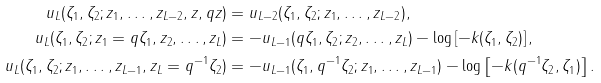Convert formula to latex. <formula><loc_0><loc_0><loc_500><loc_500>u _ { L } ( \zeta _ { 1 } , \zeta _ { 2 } ; z _ { 1 } , \dots , z _ { L - 2 } , z , q z ) & = u _ { L - 2 } ( \zeta _ { 1 } , \zeta _ { 2 } ; z _ { 1 } , \dots , z _ { L - 2 } ) , \\ u _ { L } ( \zeta _ { 1 } , \zeta _ { 2 } ; z _ { 1 } = q \zeta _ { 1 } , z _ { 2 } , \dots , z _ { L } ) & = - u _ { L - 1 } ( q \zeta _ { 1 } , \zeta _ { 2 } ; z _ { 2 } , \dots , z _ { L } ) - \log \left [ - k ( \zeta _ { 1 } , \zeta _ { 2 } ) \right ] , \\ u _ { L } ( \zeta _ { 1 } , \zeta _ { 2 } ; z _ { 1 } , \dots , z _ { L - 1 } , z _ { L } = q ^ { - 1 } \zeta _ { 2 } ) & = - u _ { L - 1 } ( \zeta _ { 1 } , q ^ { - 1 } \zeta _ { 2 } ; z _ { 1 } , \dots , z _ { L - 1 } ) - \log \left [ - k ( q ^ { - 1 } \zeta _ { 2 } , \zeta _ { 1 } ) \right ] .</formula> 